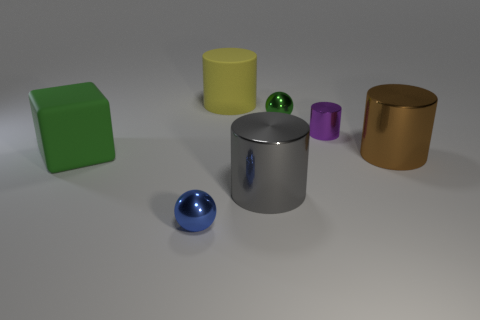Are there fewer big cylinders that are in front of the big brown thing than big matte objects on the right side of the green rubber thing?
Provide a short and direct response. No. The other big thing that is the same material as the big yellow object is what color?
Offer a very short reply. Green. Is there a small shiny thing behind the small metallic ball that is behind the large green cube?
Your answer should be compact. No. There is a metallic ball that is the same size as the blue thing; what color is it?
Offer a terse response. Green. What number of objects are either big gray cylinders or metal objects?
Give a very brief answer. 5. There is a shiny object on the left side of the big shiny thing on the left side of the big cylinder that is right of the small green metal object; what is its size?
Your response must be concise. Small. What number of balls are the same color as the block?
Provide a succinct answer. 1. What number of green things have the same material as the blue sphere?
Offer a terse response. 1. What number of objects are small gray cubes or green things that are to the right of the big yellow rubber cylinder?
Your answer should be compact. 1. The big matte object on the right side of the metallic thing left of the rubber thing that is right of the small blue metal sphere is what color?
Your answer should be compact. Yellow. 